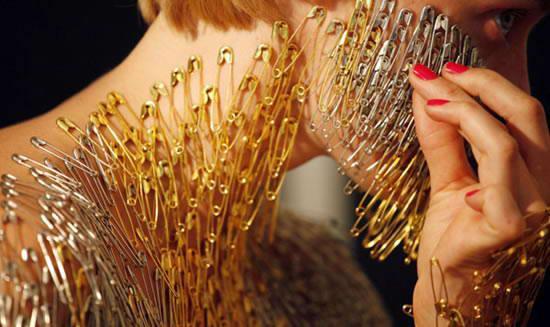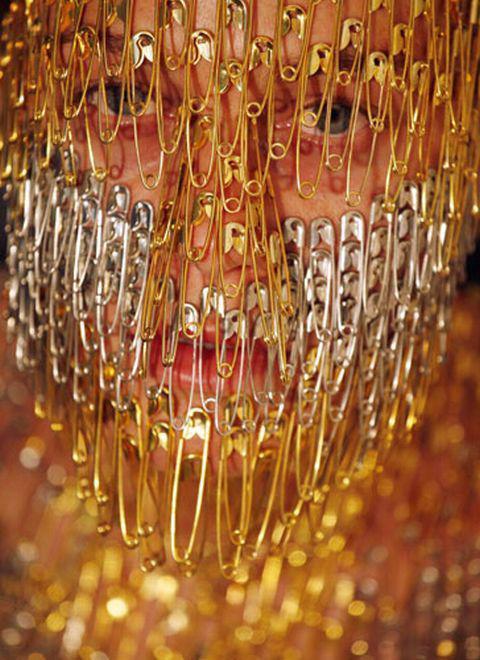The first image is the image on the left, the second image is the image on the right. Evaluate the accuracy of this statement regarding the images: "An image shows flat beaded items in geometric shapes.". Is it true? Answer yes or no. No. 